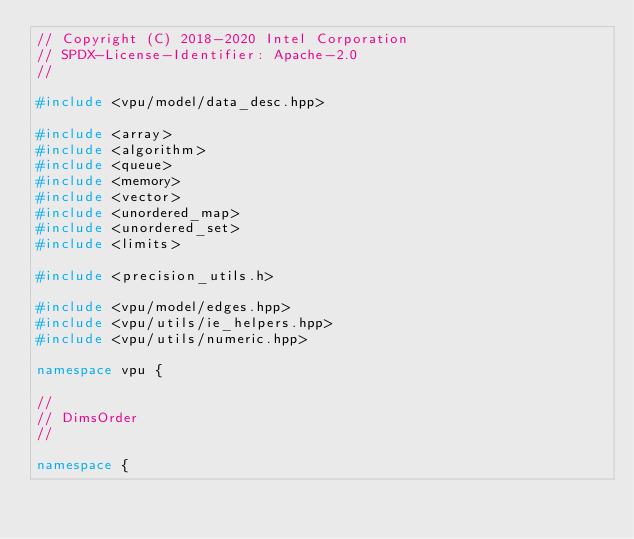Convert code to text. <code><loc_0><loc_0><loc_500><loc_500><_C++_>// Copyright (C) 2018-2020 Intel Corporation
// SPDX-License-Identifier: Apache-2.0
//

#include <vpu/model/data_desc.hpp>

#include <array>
#include <algorithm>
#include <queue>
#include <memory>
#include <vector>
#include <unordered_map>
#include <unordered_set>
#include <limits>

#include <precision_utils.h>

#include <vpu/model/edges.hpp>
#include <vpu/utils/ie_helpers.hpp>
#include <vpu/utils/numeric.hpp>

namespace vpu {

//
// DimsOrder
//

namespace {
</code> 